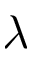Convert formula to latex. <formula><loc_0><loc_0><loc_500><loc_500>\lambda</formula> 